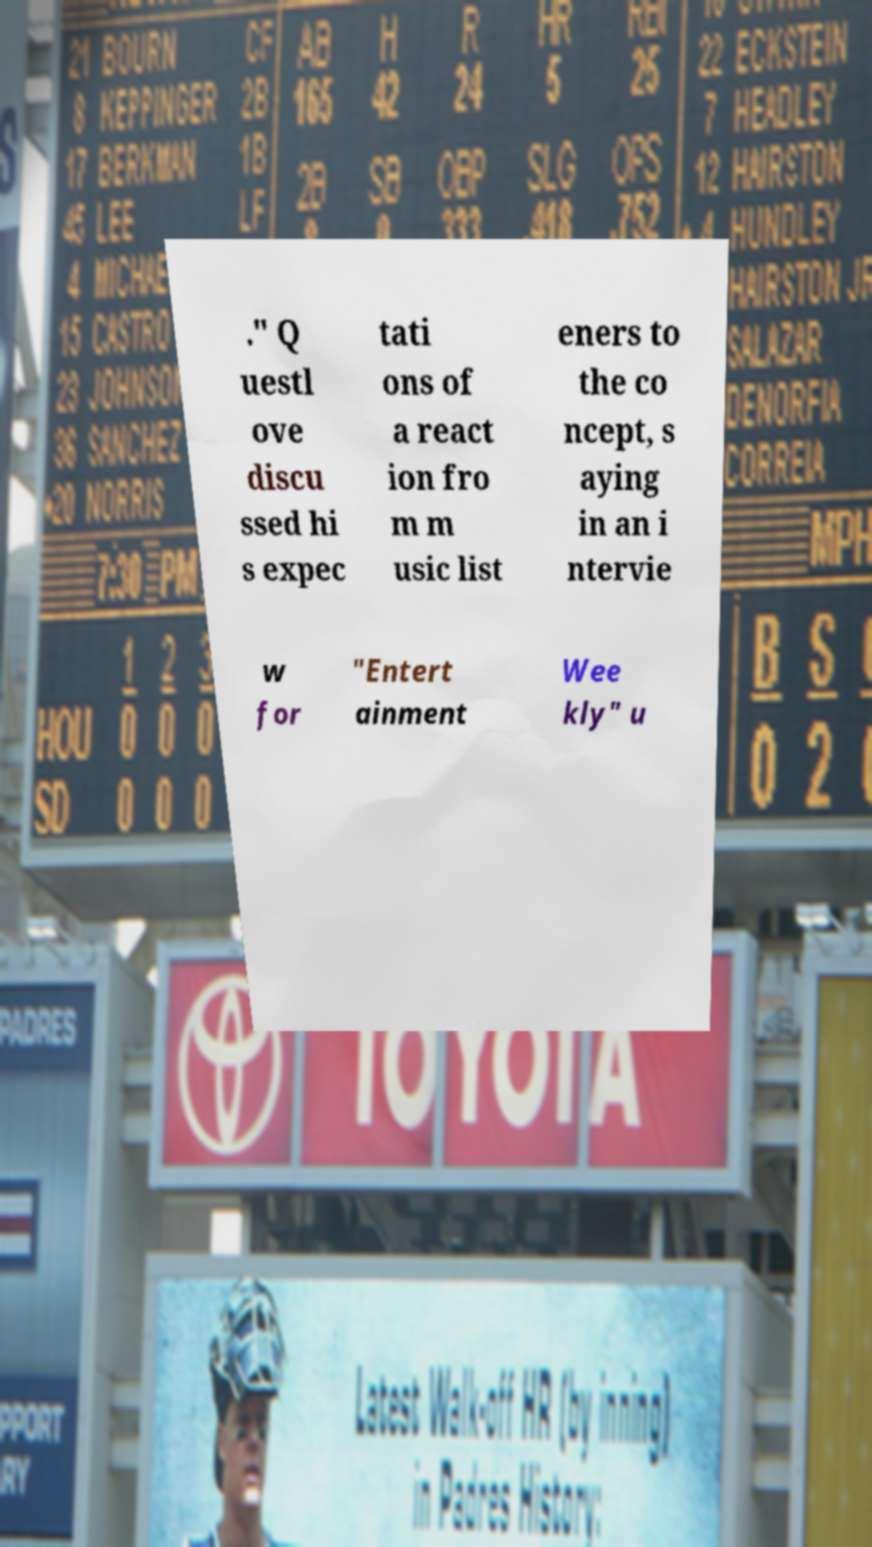Could you extract and type out the text from this image? ." Q uestl ove discu ssed hi s expec tati ons of a react ion fro m m usic list eners to the co ncept, s aying in an i ntervie w for "Entert ainment Wee kly" u 